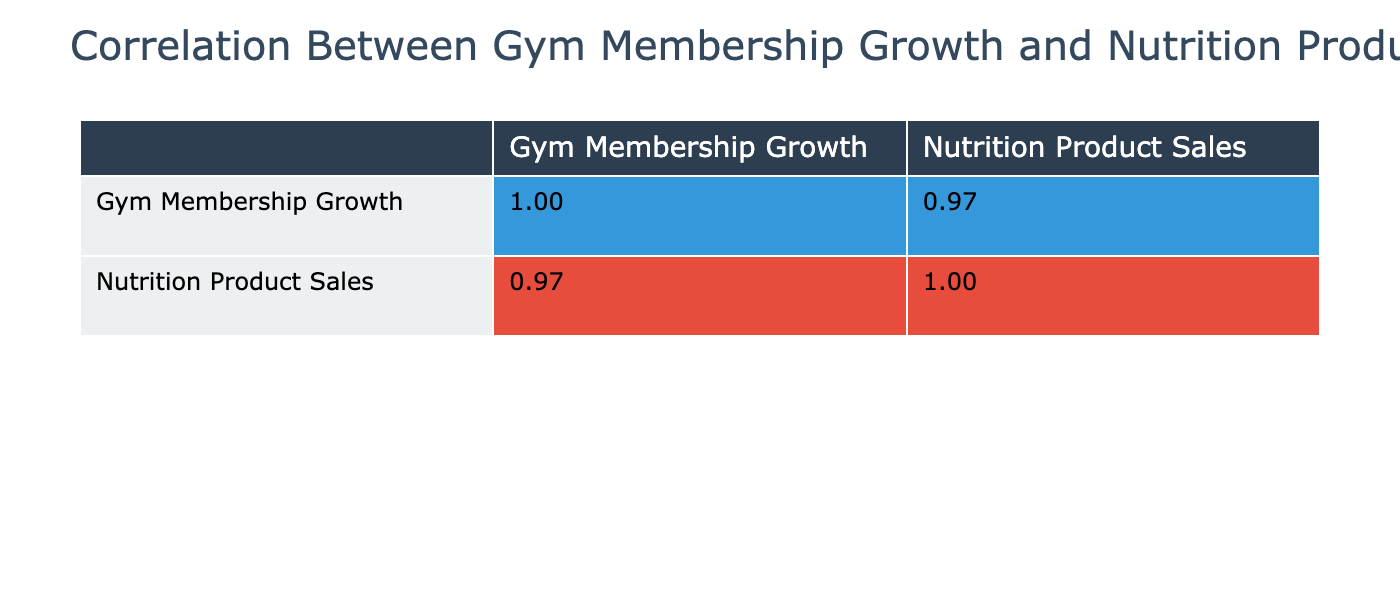What is the correlation coefficient between Gym Membership Growth and Nutrition Product Sales? The correlation coefficient is found at the cell where these two metrics intersect. Looking at the table, the value is approximately 0.92, which indicates a strong positive correlation between the two variables.
Answer: 0.92 Which gym had the highest growth in membership? By reviewing the Gym Membership Growth values, the gym with the highest percentage is Cardio Haven at 20.1%. This is the maximum value among all the gyms listed.
Answer: Cardio Haven Is it true that Strength Society has a higher percentage of Nutrition Product Sales Achievement compared to Gym Membership Growth? Looking at the data for Strength Society, the Gym Membership Growth is 8.4% and the Nutrition Product Sales Achievement is 10.0%. Since 10.0% is greater than 8.4%, the statement is true.
Answer: Yes What is the average Gym Membership Growth Percentage across all gyms? To find the average, sum the Gym Membership Growth Percentages: 15.2 + 10.5 + 8.4 + 12.3 + 20.1 + 5.0 + 18.0 + 16.7 + 9.0 + 14.5 = 120.7. There are 10 gyms, so the average is 120.7 / 10 = 12.07%.
Answer: 12.07% Which gym has the lowest Nutrition Product Sales Achievement Percentage and what is it? The lowest Nutrition Product Sales Achievement Percentage can be found by looking for the minimum value in that column. It is Zen Fitness at 7.5%.
Answer: Zen Fitness, 7.5% 